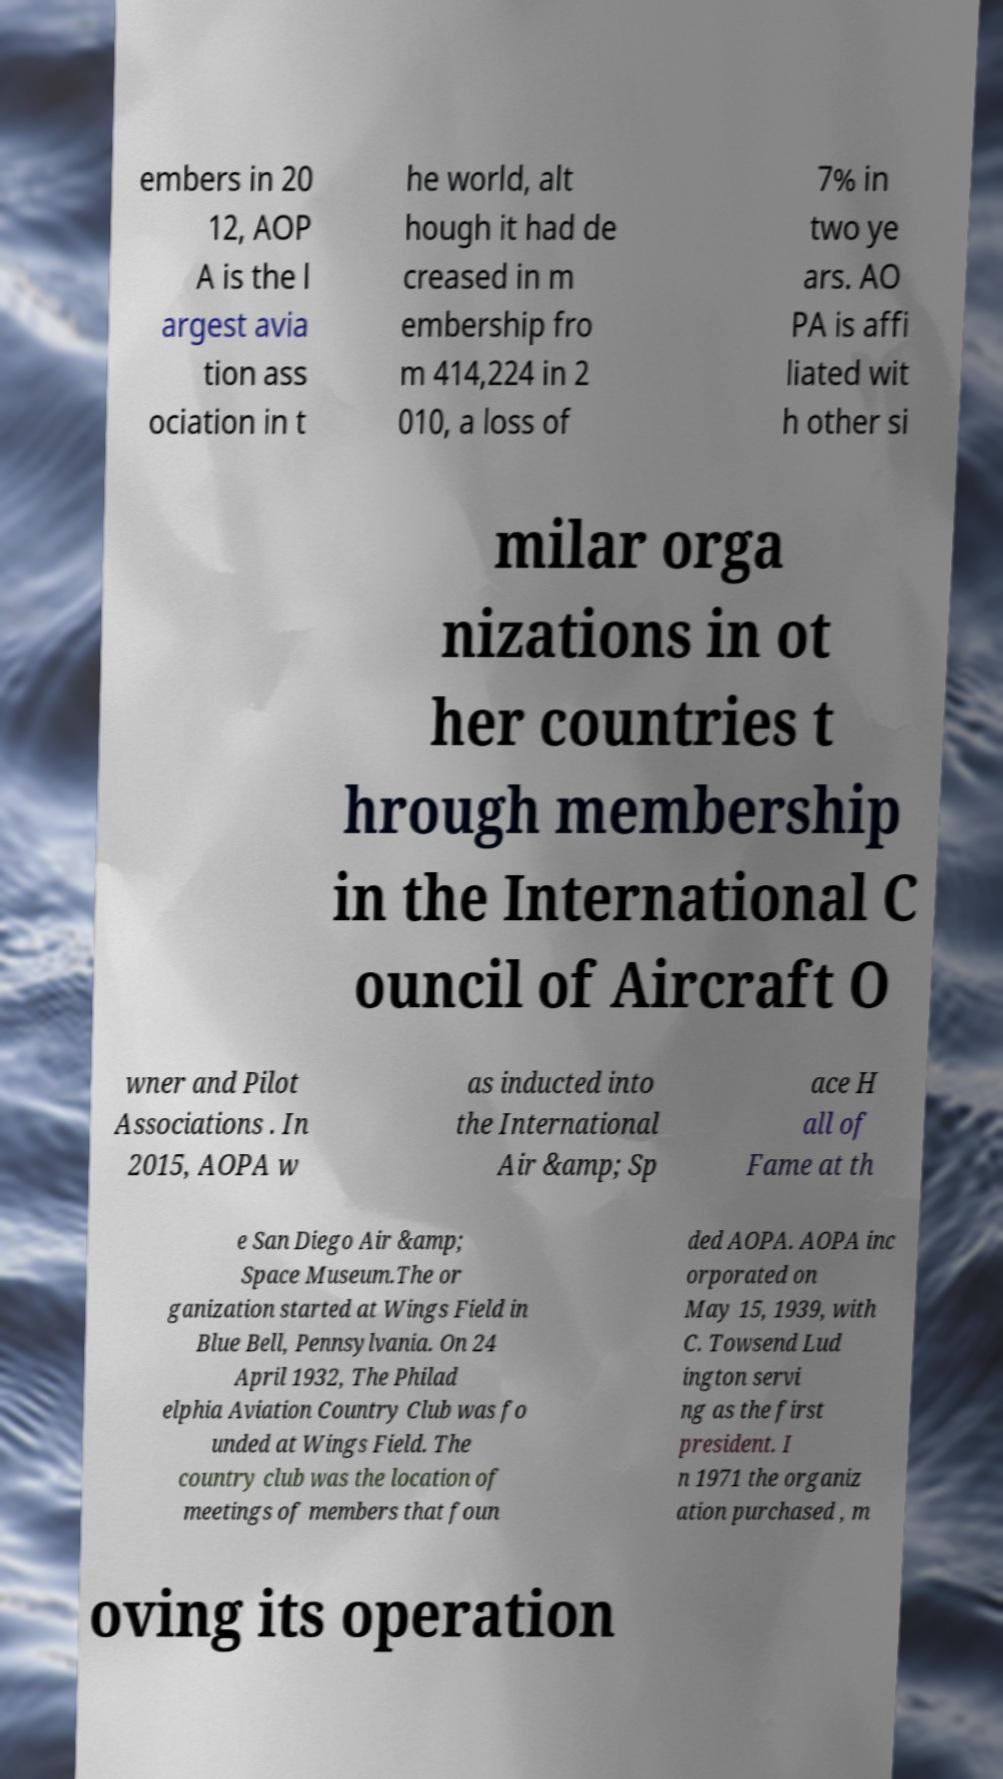Can you accurately transcribe the text from the provided image for me? embers in 20 12, AOP A is the l argest avia tion ass ociation in t he world, alt hough it had de creased in m embership fro m 414,224 in 2 010, a loss of 7% in two ye ars. AO PA is affi liated wit h other si milar orga nizations in ot her countries t hrough membership in the International C ouncil of Aircraft O wner and Pilot Associations . In 2015, AOPA w as inducted into the International Air &amp; Sp ace H all of Fame at th e San Diego Air &amp; Space Museum.The or ganization started at Wings Field in Blue Bell, Pennsylvania. On 24 April 1932, The Philad elphia Aviation Country Club was fo unded at Wings Field. The country club was the location of meetings of members that foun ded AOPA. AOPA inc orporated on May 15, 1939, with C. Towsend Lud ington servi ng as the first president. I n 1971 the organiz ation purchased , m oving its operation 